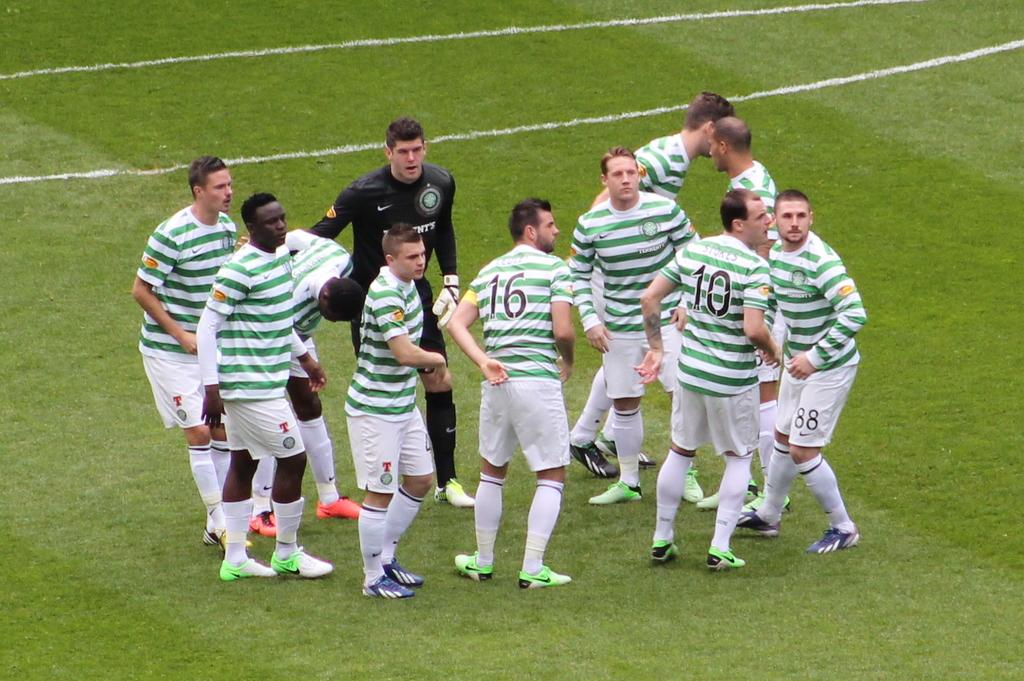<image>
Present a compact description of the photo's key features. A group of men with 16 and 10 on their green and white shirts. 